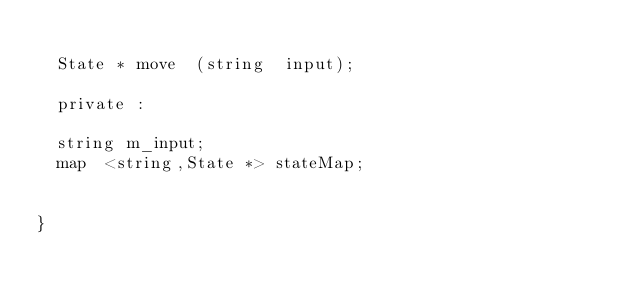<code> <loc_0><loc_0><loc_500><loc_500><_C_>   
  State * move  (string  input);

  private : 

  string m_input;
  map  <string,State *> stateMap;


}
</code> 